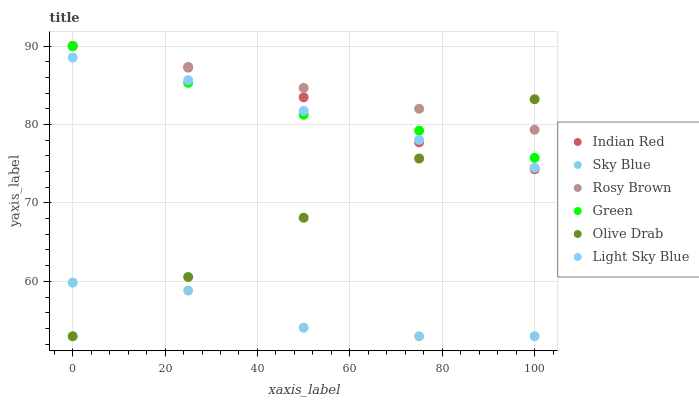Does Sky Blue have the minimum area under the curve?
Answer yes or no. Yes. Does Rosy Brown have the maximum area under the curve?
Answer yes or no. Yes. Does Light Sky Blue have the minimum area under the curve?
Answer yes or no. No. Does Light Sky Blue have the maximum area under the curve?
Answer yes or no. No. Is Olive Drab the smoothest?
Answer yes or no. Yes. Is Sky Blue the roughest?
Answer yes or no. Yes. Is Light Sky Blue the smoothest?
Answer yes or no. No. Is Light Sky Blue the roughest?
Answer yes or no. No. Does Sky Blue have the lowest value?
Answer yes or no. Yes. Does Light Sky Blue have the lowest value?
Answer yes or no. No. Does Indian Red have the highest value?
Answer yes or no. Yes. Does Light Sky Blue have the highest value?
Answer yes or no. No. Is Sky Blue less than Green?
Answer yes or no. Yes. Is Light Sky Blue greater than Sky Blue?
Answer yes or no. Yes. Does Rosy Brown intersect Indian Red?
Answer yes or no. Yes. Is Rosy Brown less than Indian Red?
Answer yes or no. No. Is Rosy Brown greater than Indian Red?
Answer yes or no. No. Does Sky Blue intersect Green?
Answer yes or no. No. 